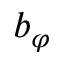<formula> <loc_0><loc_0><loc_500><loc_500>b _ { \varphi }</formula> 